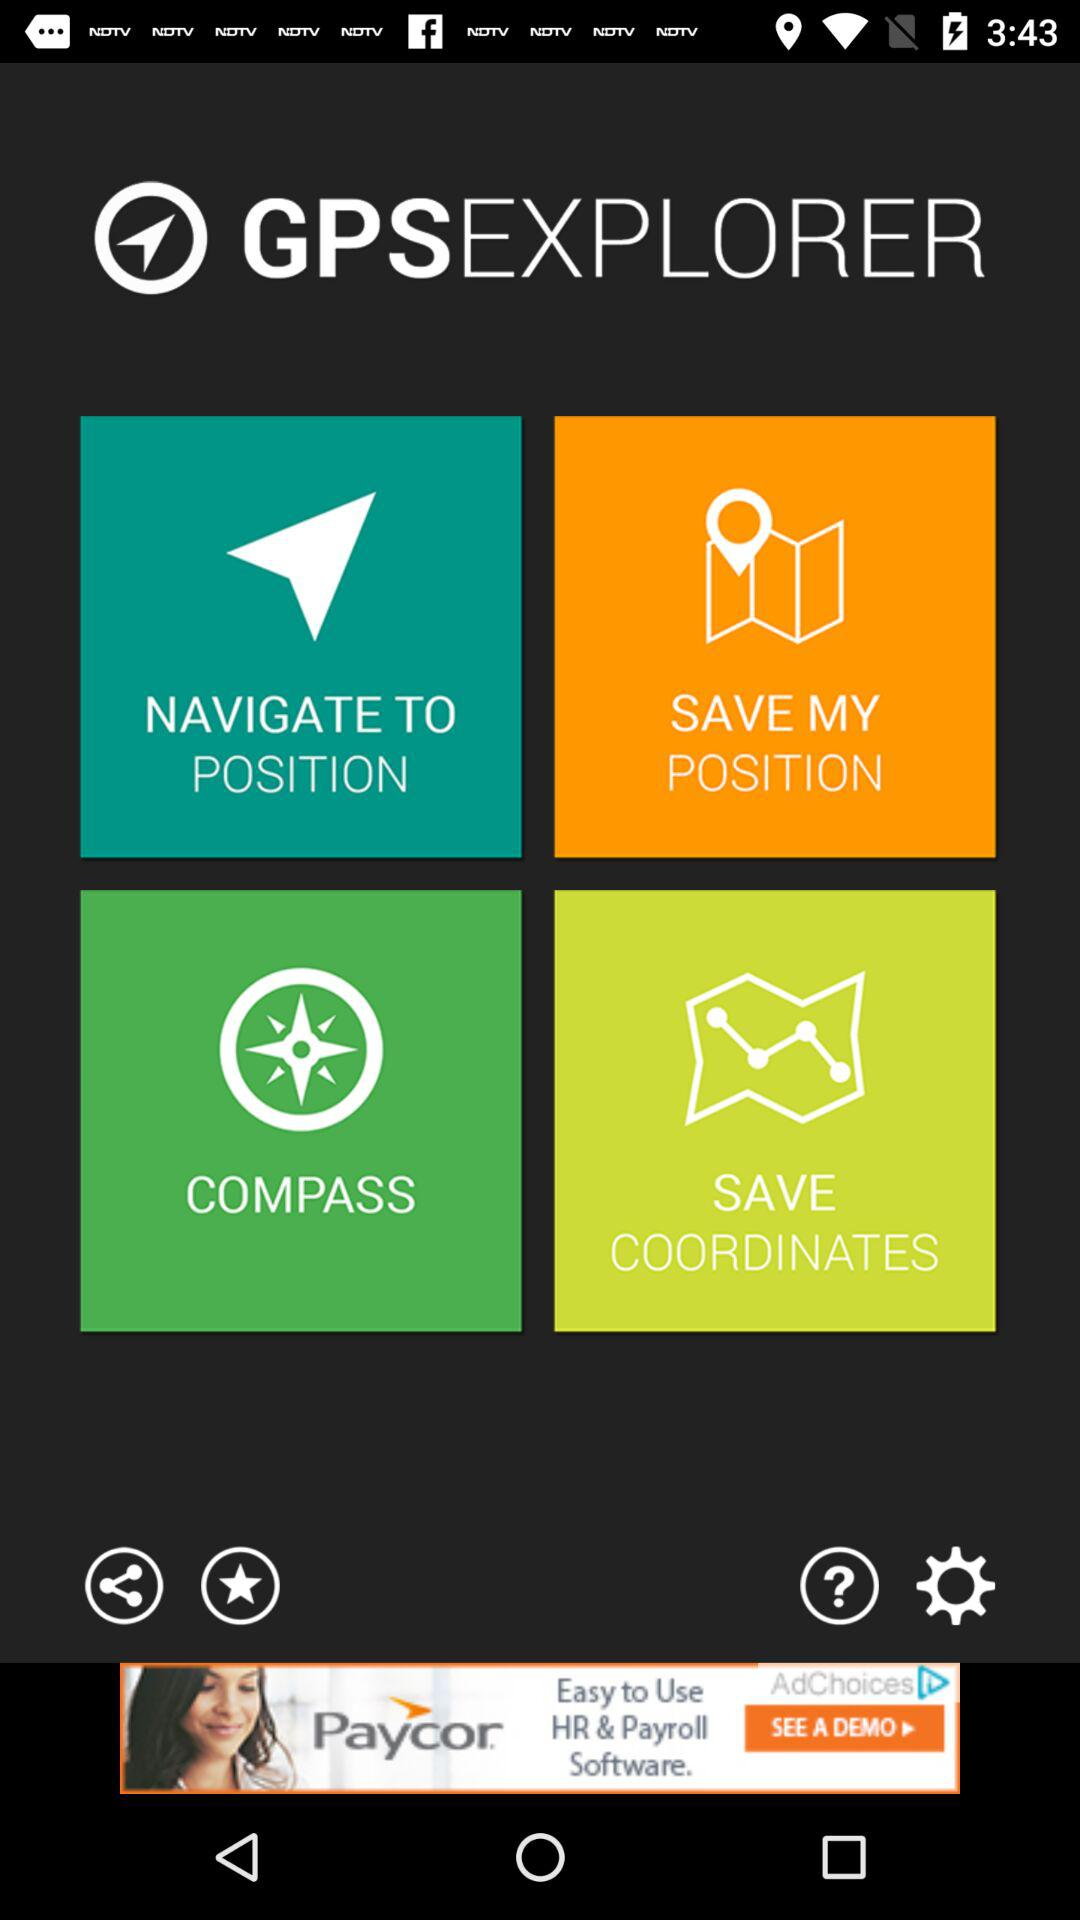What is the name of the application? The name of the application is "GPSEXPLORER". 